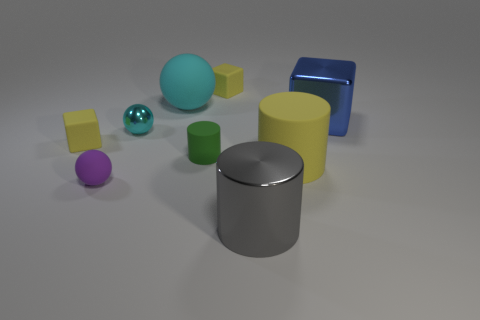How many red objects are shiny things or large blocks?
Provide a succinct answer. 0. There is a small yellow object that is to the left of the tiny green matte cylinder; what material is it?
Make the answer very short. Rubber. There is a sphere in front of the small cyan metallic thing; how many large blue cubes are behind it?
Keep it short and to the point. 1. What number of cyan matte objects have the same shape as the purple rubber thing?
Offer a terse response. 1. How many tiny metal objects are there?
Your answer should be compact. 1. There is a rubber cube that is behind the big blue shiny object; what color is it?
Provide a short and direct response. Yellow. The small object that is behind the large object that is on the left side of the gray cylinder is what color?
Your answer should be very brief. Yellow. What is the color of the other cylinder that is the same size as the gray cylinder?
Your answer should be very brief. Yellow. How many matte objects are both behind the small purple matte object and left of the metal cylinder?
Provide a short and direct response. 4. There is a big rubber thing that is the same color as the small metallic sphere; what shape is it?
Your answer should be very brief. Sphere. 